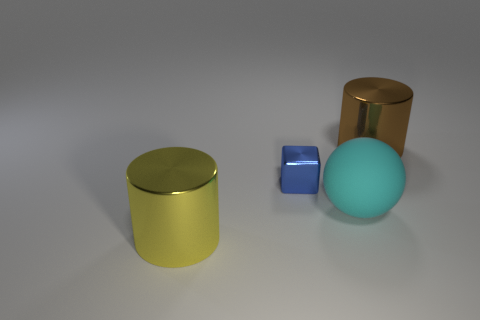How many things are either small blocks in front of the brown shiny thing or brown objects?
Ensure brevity in your answer.  2. How many rubber objects are on the right side of the metal cylinder that is on the right side of the big yellow shiny cylinder?
Offer a terse response. 0. There is a cylinder that is behind the metal cylinder that is to the left of the big shiny cylinder on the right side of the yellow object; what size is it?
Offer a very short reply. Large. The yellow metal thing that is the same shape as the big brown thing is what size?
Ensure brevity in your answer.  Large. What number of things are metal objects in front of the small metallic cube or large metal objects that are in front of the blue metallic object?
Offer a terse response. 1. There is a big metal object that is to the right of the object that is in front of the cyan ball; what shape is it?
Your response must be concise. Cylinder. Are there any other things that have the same color as the tiny object?
Keep it short and to the point. No. Is there anything else that is the same size as the metallic block?
Your response must be concise. No. How many things are big yellow shiny objects or big blue rubber blocks?
Provide a succinct answer. 1. Are there any metallic cylinders of the same size as the sphere?
Provide a succinct answer. Yes. 